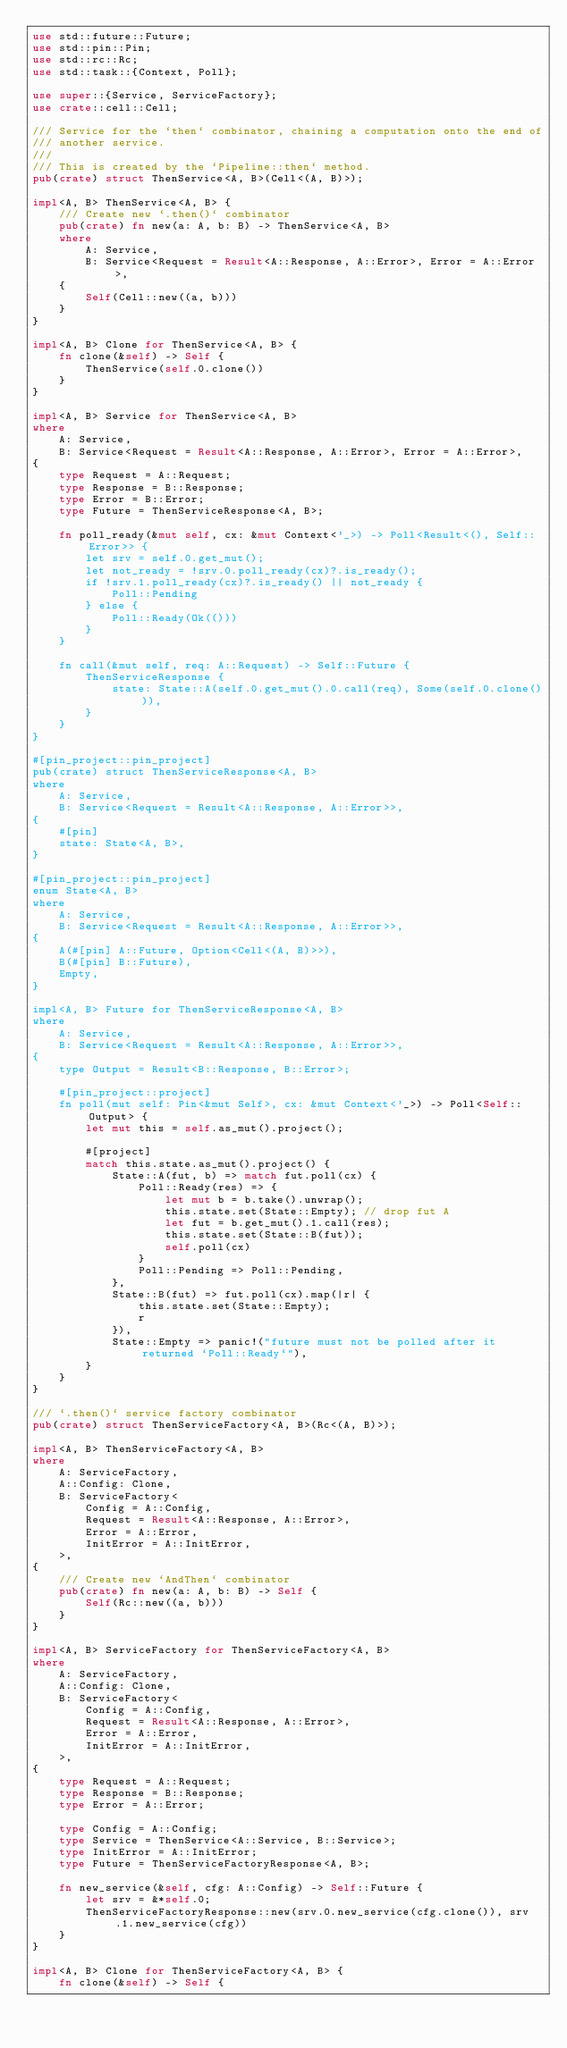<code> <loc_0><loc_0><loc_500><loc_500><_Rust_>use std::future::Future;
use std::pin::Pin;
use std::rc::Rc;
use std::task::{Context, Poll};

use super::{Service, ServiceFactory};
use crate::cell::Cell;

/// Service for the `then` combinator, chaining a computation onto the end of
/// another service.
///
/// This is created by the `Pipeline::then` method.
pub(crate) struct ThenService<A, B>(Cell<(A, B)>);

impl<A, B> ThenService<A, B> {
    /// Create new `.then()` combinator
    pub(crate) fn new(a: A, b: B) -> ThenService<A, B>
    where
        A: Service,
        B: Service<Request = Result<A::Response, A::Error>, Error = A::Error>,
    {
        Self(Cell::new((a, b)))
    }
}

impl<A, B> Clone for ThenService<A, B> {
    fn clone(&self) -> Self {
        ThenService(self.0.clone())
    }
}

impl<A, B> Service for ThenService<A, B>
where
    A: Service,
    B: Service<Request = Result<A::Response, A::Error>, Error = A::Error>,
{
    type Request = A::Request;
    type Response = B::Response;
    type Error = B::Error;
    type Future = ThenServiceResponse<A, B>;

    fn poll_ready(&mut self, cx: &mut Context<'_>) -> Poll<Result<(), Self::Error>> {
        let srv = self.0.get_mut();
        let not_ready = !srv.0.poll_ready(cx)?.is_ready();
        if !srv.1.poll_ready(cx)?.is_ready() || not_ready {
            Poll::Pending
        } else {
            Poll::Ready(Ok(()))
        }
    }

    fn call(&mut self, req: A::Request) -> Self::Future {
        ThenServiceResponse {
            state: State::A(self.0.get_mut().0.call(req), Some(self.0.clone())),
        }
    }
}

#[pin_project::pin_project]
pub(crate) struct ThenServiceResponse<A, B>
where
    A: Service,
    B: Service<Request = Result<A::Response, A::Error>>,
{
    #[pin]
    state: State<A, B>,
}

#[pin_project::pin_project]
enum State<A, B>
where
    A: Service,
    B: Service<Request = Result<A::Response, A::Error>>,
{
    A(#[pin] A::Future, Option<Cell<(A, B)>>),
    B(#[pin] B::Future),
    Empty,
}

impl<A, B> Future for ThenServiceResponse<A, B>
where
    A: Service,
    B: Service<Request = Result<A::Response, A::Error>>,
{
    type Output = Result<B::Response, B::Error>;

    #[pin_project::project]
    fn poll(mut self: Pin<&mut Self>, cx: &mut Context<'_>) -> Poll<Self::Output> {
        let mut this = self.as_mut().project();

        #[project]
        match this.state.as_mut().project() {
            State::A(fut, b) => match fut.poll(cx) {
                Poll::Ready(res) => {
                    let mut b = b.take().unwrap();
                    this.state.set(State::Empty); // drop fut A
                    let fut = b.get_mut().1.call(res);
                    this.state.set(State::B(fut));
                    self.poll(cx)
                }
                Poll::Pending => Poll::Pending,
            },
            State::B(fut) => fut.poll(cx).map(|r| {
                this.state.set(State::Empty);
                r
            }),
            State::Empty => panic!("future must not be polled after it returned `Poll::Ready`"),
        }
    }
}

/// `.then()` service factory combinator
pub(crate) struct ThenServiceFactory<A, B>(Rc<(A, B)>);

impl<A, B> ThenServiceFactory<A, B>
where
    A: ServiceFactory,
    A::Config: Clone,
    B: ServiceFactory<
        Config = A::Config,
        Request = Result<A::Response, A::Error>,
        Error = A::Error,
        InitError = A::InitError,
    >,
{
    /// Create new `AndThen` combinator
    pub(crate) fn new(a: A, b: B) -> Self {
        Self(Rc::new((a, b)))
    }
}

impl<A, B> ServiceFactory for ThenServiceFactory<A, B>
where
    A: ServiceFactory,
    A::Config: Clone,
    B: ServiceFactory<
        Config = A::Config,
        Request = Result<A::Response, A::Error>,
        Error = A::Error,
        InitError = A::InitError,
    >,
{
    type Request = A::Request;
    type Response = B::Response;
    type Error = A::Error;

    type Config = A::Config;
    type Service = ThenService<A::Service, B::Service>;
    type InitError = A::InitError;
    type Future = ThenServiceFactoryResponse<A, B>;

    fn new_service(&self, cfg: A::Config) -> Self::Future {
        let srv = &*self.0;
        ThenServiceFactoryResponse::new(srv.0.new_service(cfg.clone()), srv.1.new_service(cfg))
    }
}

impl<A, B> Clone for ThenServiceFactory<A, B> {
    fn clone(&self) -> Self {</code> 